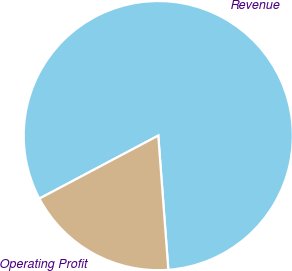Convert chart. <chart><loc_0><loc_0><loc_500><loc_500><pie_chart><fcel>Revenue<fcel>Operating Profit<nl><fcel>81.56%<fcel>18.44%<nl></chart> 